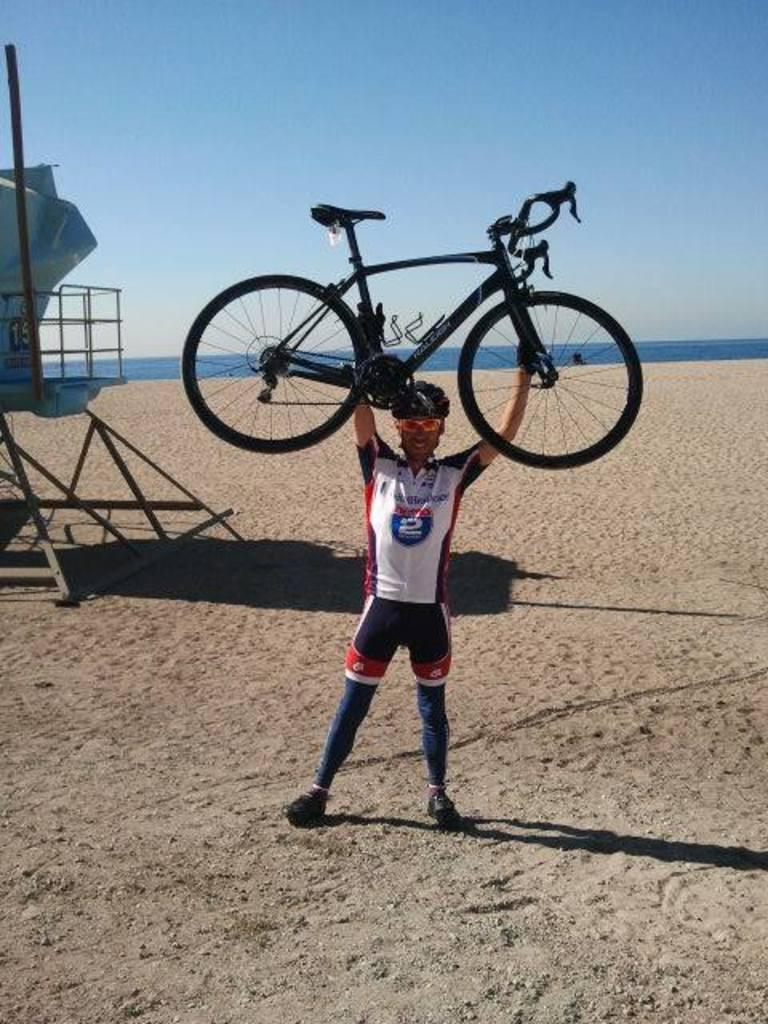<image>
Relay a brief, clear account of the picture shown. A man with the number 2 on his shirt is holding a bike over his head. 